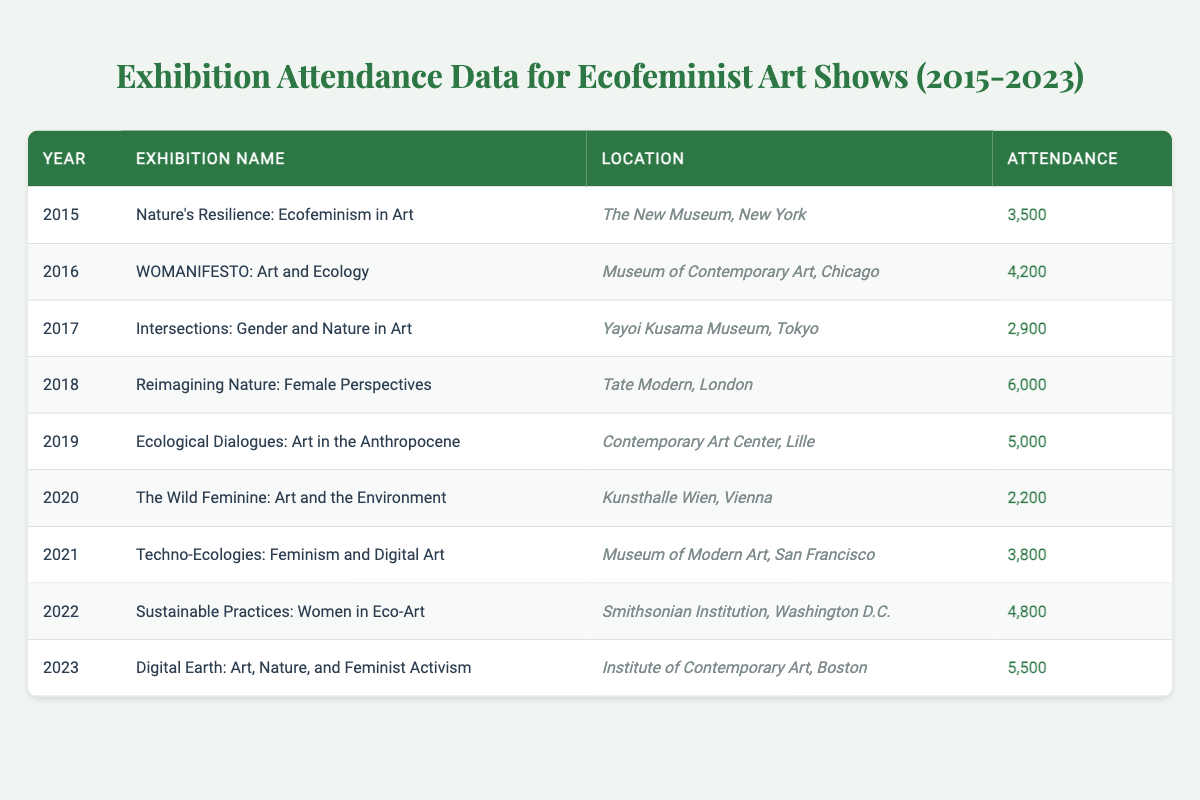What was the attendance for the exhibition titled "Reimagining Nature: Female Perspectives"? The table lists the exhibition name along with the corresponding attendance figures. Looking specifically for "Reimagining Nature: Female Perspectives," I see that the attendance figure is 6000.
Answer: 6000 Which exhibition had the lowest attendance, and what was that number? By examining the attendance figures for each exhibition in the table, the lowest attendance is for "The Wild Feminine: Art and the Environment" with an attendance of 2200.
Answer: 2200 In which year did the highest attendance occur, and what was the number? The highest attendance can be identified by analyzing all yearly data. Checking each exhibition's attendance, "Reimagining Nature: Female Perspectives" in 2018 reached the highest number at 6000.
Answer: 2018, 6000 What is the total attendance across all exhibitions from 2015 to 2023? To find the total attendance, I will add all the attendance figures listed: 3500 + 4200 + 2900 + 6000 + 5000 + 2200 + 3800 + 4800 + 5500. The sum totals to 33500.
Answer: 33500 Is it true that more than half of the exhibitions had an attendance higher than 4000? There are 9 exhibitions in total, and measuring those with attendance above 4000 gives the following: "WOMANIFESTO: Art and Ecology," "Reimagining Nature: Female Perspectives," "Ecological Dialogues: Art in the Anthropocene," "Sustainable Practices: Women in Eco-Art," and "Digital Earth: Art, Nature, and Feminist Activism." That's 5 out of 9, which is more than half.
Answer: Yes What was the average attendance for the exhibitions held in years where the attendance surpassed 4000? First, identify and list the years and attendance where attendance is above 4000: 4200 (2016), 6000 (2018), 5000 (2019), 4800 (2022), 5500 (2023). Now add these values: 4200 + 6000 + 5000 + 4800 + 5500 = 25500. There are 5 exhibitions, so average = 25500 / 5 = 5100.
Answer: 5100 How many exhibitions were held in the year 2020 or later, and what was the attendance for those? Looking at the table, the exhibitions for 2020 or later are "The Wild Feminine: Art and the Environment" (2200), "Techno-Ecologies: Feminism and Digital Art" (3800), "Sustainable Practices: Women in Eco-Art" (4800), and "Digital Earth: Art, Nature, and Feminist Activism" (5500). That's a total of 4 exhibitions.
Answer: 4 Which exhibition held at the Smithsonian Institution had an attendance above 4000? The table specifically indicates "Sustainable Practices: Women in Eco-Art," located at the Smithsonian Institution, with an attendance of 4800, which is above 4000.
Answer: Yes 